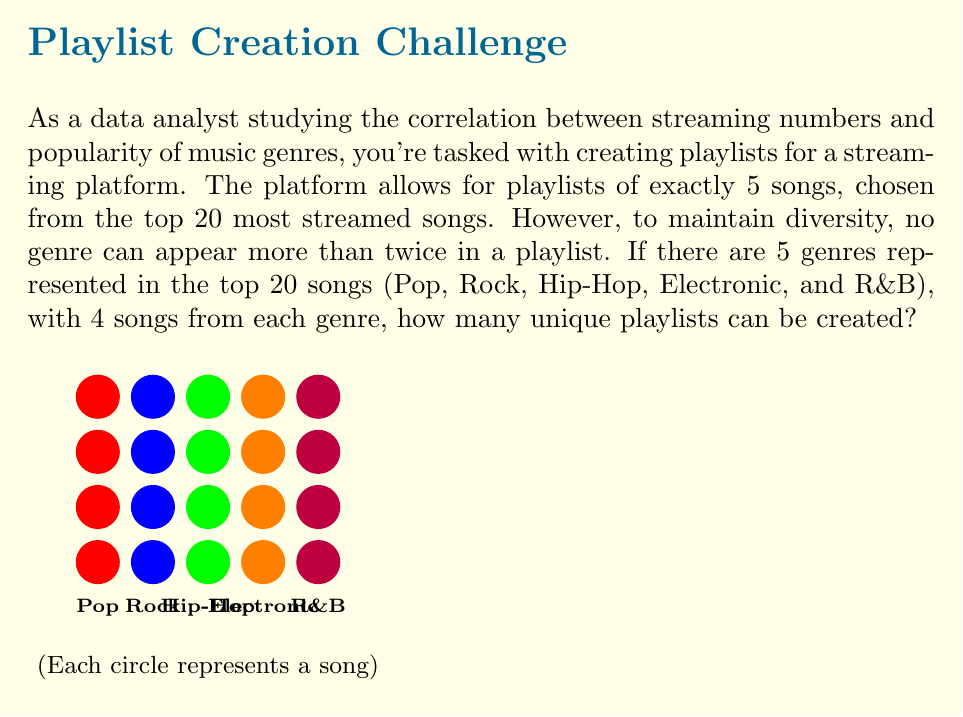What is the answer to this math problem? Let's approach this step-by-step using permutation groups:

1) First, we need to consider the possible genre combinations. We can have:
   - 5 different genres (1 from each)
   - 4 different genres (2 from one, 1 from each of three others)

2) For the case of 5 different genres:
   - We have $\binom{5}{5} = 1$ way to choose 5 genres
   - For each genre, we have 4 songs to choose from
   - This gives us $4^5 = 1024$ possibilities

3) For the case of 4 different genres:
   - We have $\binom{5}{4} = 5$ ways to choose 4 genres
   - We then need to choose which genre will have 2 songs: 4 choices
   - For the doubled genre, we have $\binom{4}{2} = 6$ ways to choose 2 songs
   - For each of the other 3 genres, we have 4 choices
   - This gives us $5 \cdot 4 \cdot 6 \cdot 4^3 = 7680$ possibilities

4) The total number of playlists is the sum of these two cases:
   $1024 + 7680 = 8704$

5) However, this counts each playlist multiple times based on the order of songs. We need to divide by the number of ways to arrange 5 songs:
   $8704 / 5! = 8704 / 120 = 72.5333...$

Therefore, the number of unique playlists is 72.
Answer: 72 unique playlists 